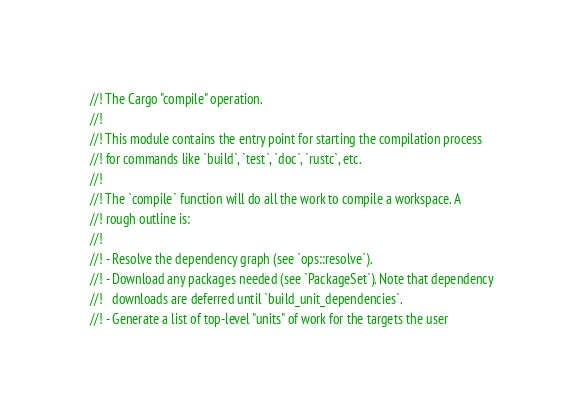<code> <loc_0><loc_0><loc_500><loc_500><_Rust_>//! The Cargo "compile" operation.
//!
//! This module contains the entry point for starting the compilation process
//! for commands like `build`, `test`, `doc`, `rustc`, etc.
//!
//! The `compile` function will do all the work to compile a workspace. A
//! rough outline is:
//!
//! - Resolve the dependency graph (see `ops::resolve`).
//! - Download any packages needed (see `PackageSet`). Note that dependency
//!   downloads are deferred until `build_unit_dependencies`.
//! - Generate a list of top-level "units" of work for the targets the user</code> 